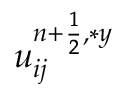<formula> <loc_0><loc_0><loc_500><loc_500>u _ { i j } ^ { { n + \frac { 1 } { 2 } } , \ast y }</formula> 